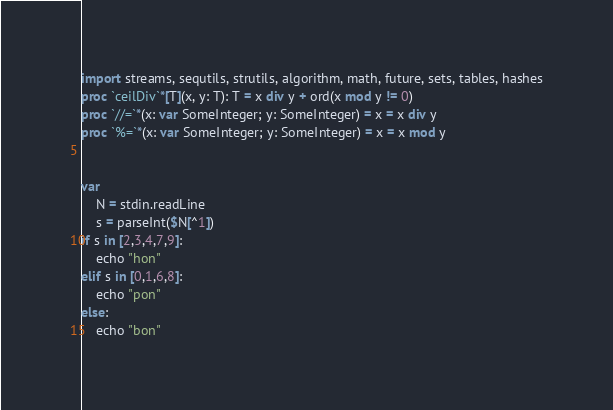<code> <loc_0><loc_0><loc_500><loc_500><_Nim_>import streams, sequtils, strutils, algorithm, math, future, sets, tables, hashes
proc `ceilDiv`*[T](x, y: T): T = x div y + ord(x mod y != 0)
proc `//=`*(x: var SomeInteger; y: SomeInteger) = x = x div y
proc `%=`*(x: var SomeInteger; y: SomeInteger) = x = x mod y


var
    N = stdin.readLine
    s = parseInt($N[^1])
if s in [2,3,4,7,9]:
    echo "hon"
elif s in [0,1,6,8]:
    echo "pon"
else:
    echo "bon"</code> 